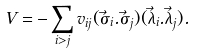<formula> <loc_0><loc_0><loc_500><loc_500>V = - \sum _ { i > j } v _ { i j } ( \vec { \sigma _ { i } } . \vec { \sigma _ { j } } ) ( \vec { \lambda _ { i } } . \vec { \lambda _ { j } } ) .</formula> 